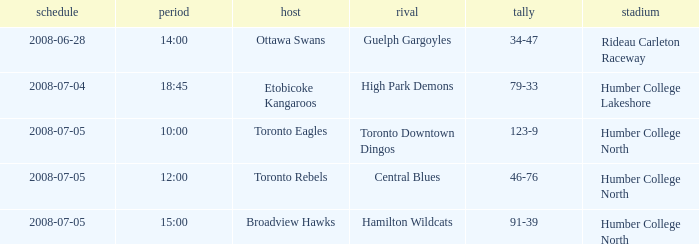What is the Ground with an Away that is central blues? Humber College North. 